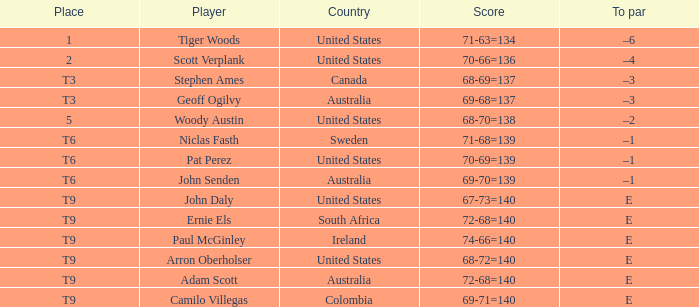What country is Adam Scott from? Australia. 